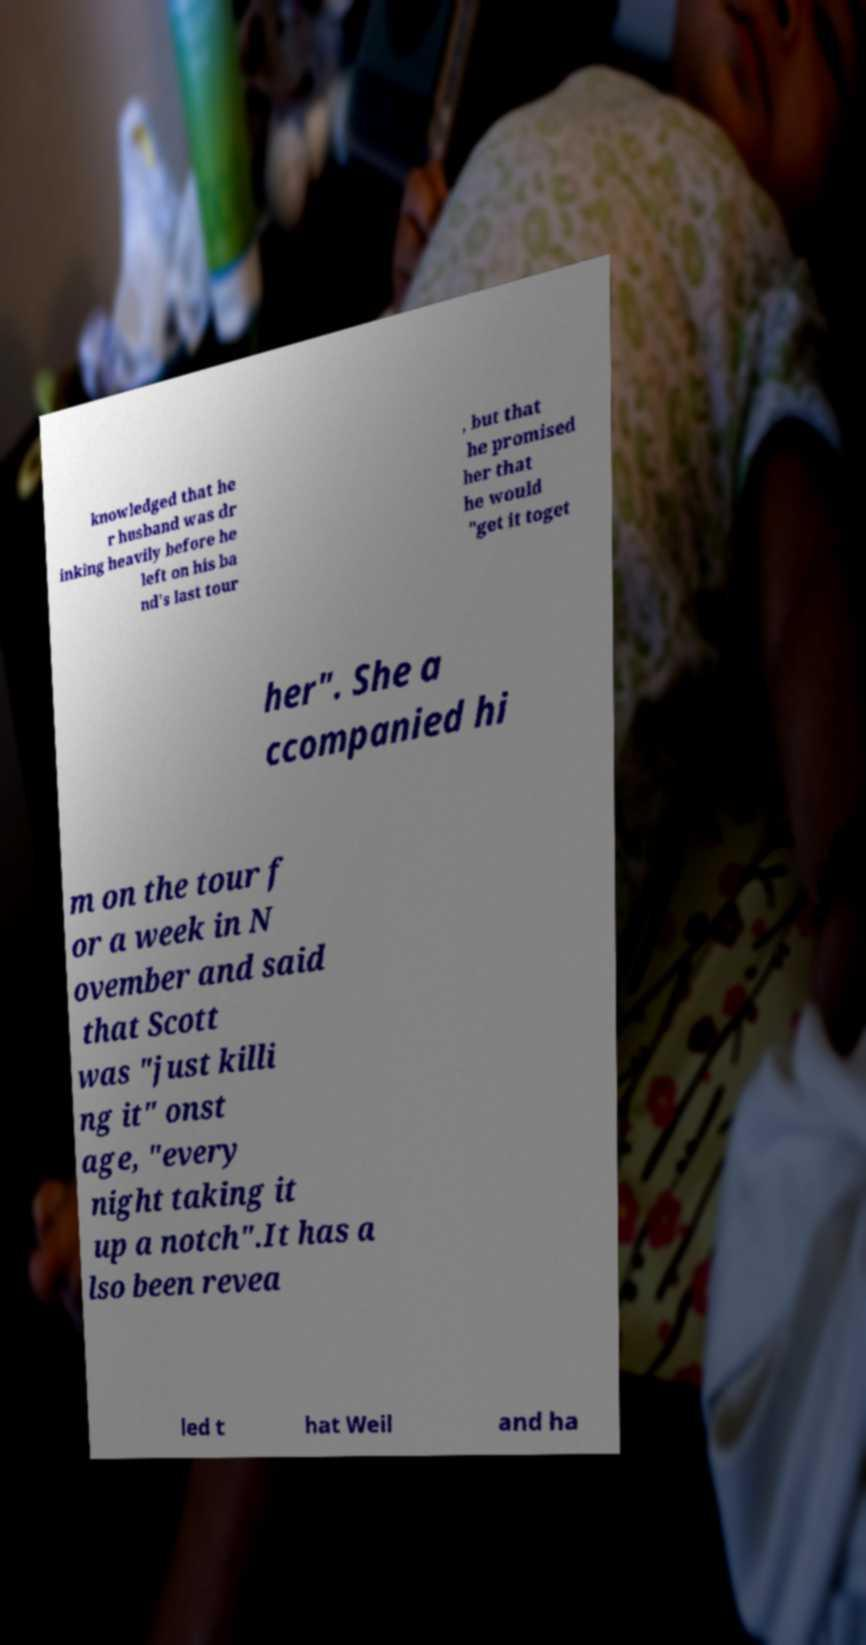Please identify and transcribe the text found in this image. knowledged that he r husband was dr inking heavily before he left on his ba nd's last tour , but that he promised her that he would "get it toget her". She a ccompanied hi m on the tour f or a week in N ovember and said that Scott was "just killi ng it" onst age, "every night taking it up a notch".It has a lso been revea led t hat Weil and ha 